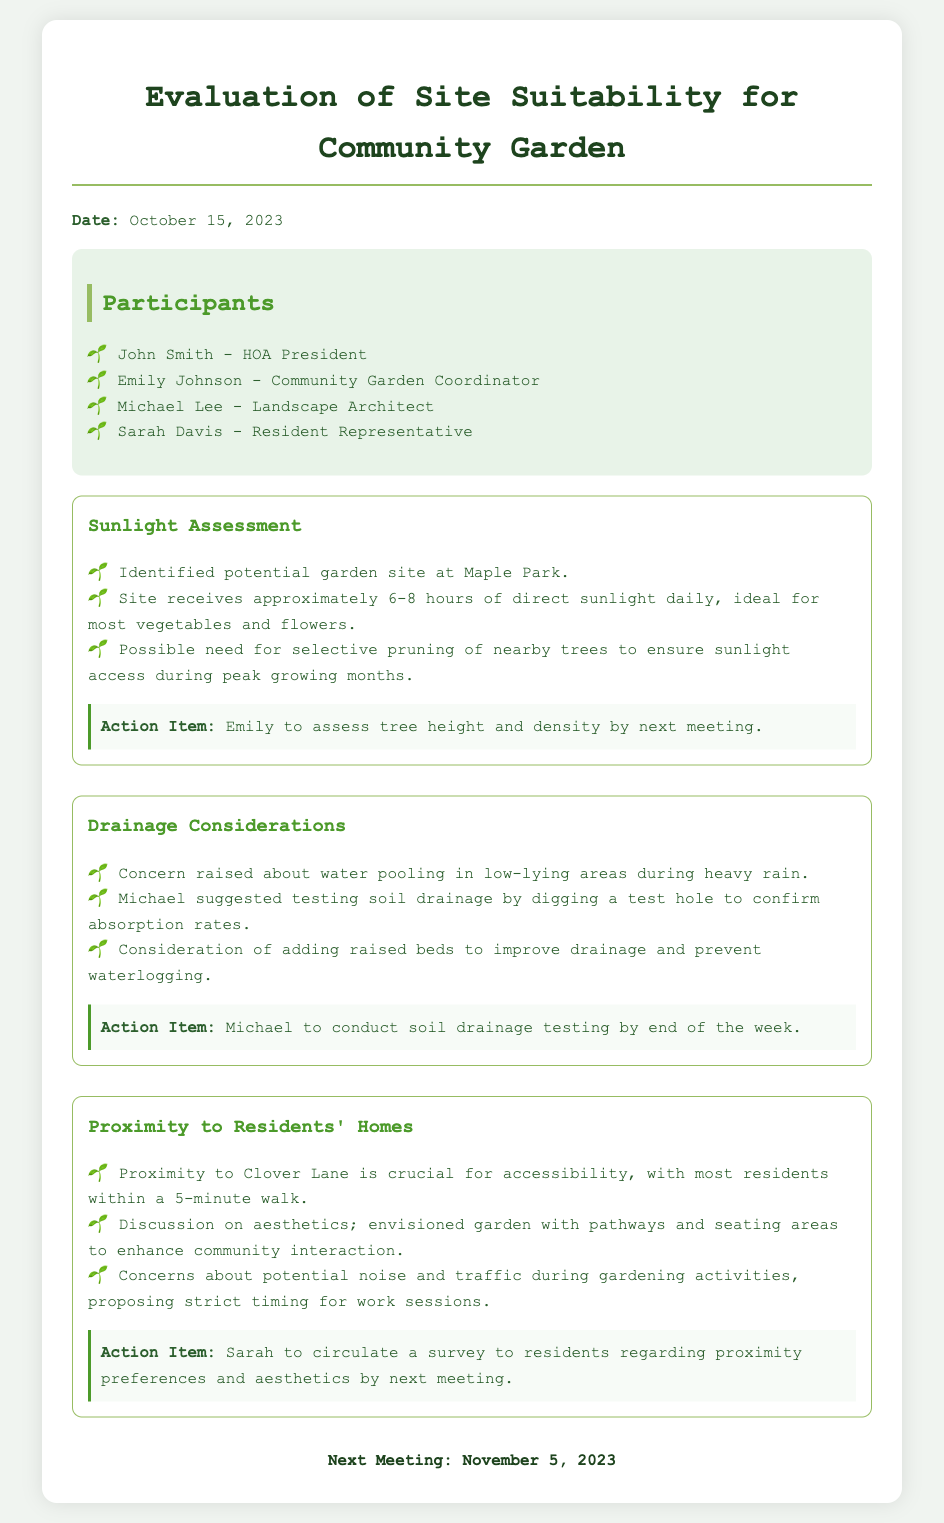what is the date of the meeting? The meeting date is specified in the document as the day it occurred, which is October 15, 2023.
Answer: October 15, 2023 who is the Community Garden Coordinator? The document lists a participant who holds the title of Community Garden Coordinator. This person is Emily Johnson.
Answer: Emily Johnson how many hours of sunlight does the site receive daily? The document states that the site receives approximately 6-8 hours of direct sunlight daily.
Answer: 6-8 hours what was the action item assigned to Emily? An action item is specified in the document for Emily regarding assessment of trees to ensure sunlight access.
Answer: Assess tree height and density what concern was raised regarding drainage? The document mentions a specific concern related to water pooling in low-lying areas during heavy rain.
Answer: Water pooling what is the proximity preference for residents? The document discusses a crucial point about accessibility for residents being within a specific distance, which is 5 minutes.
Answer: 5-minute walk what did Michael suggest to improve drainage? The document cites a suggestion made by Michael about testing soil drainage by digging a test hole.
Answer: Test soil drainage what is the upcoming meeting date? The document concludes with information about the next scheduled meeting, noting the specific date.
Answer: November 5, 2023 